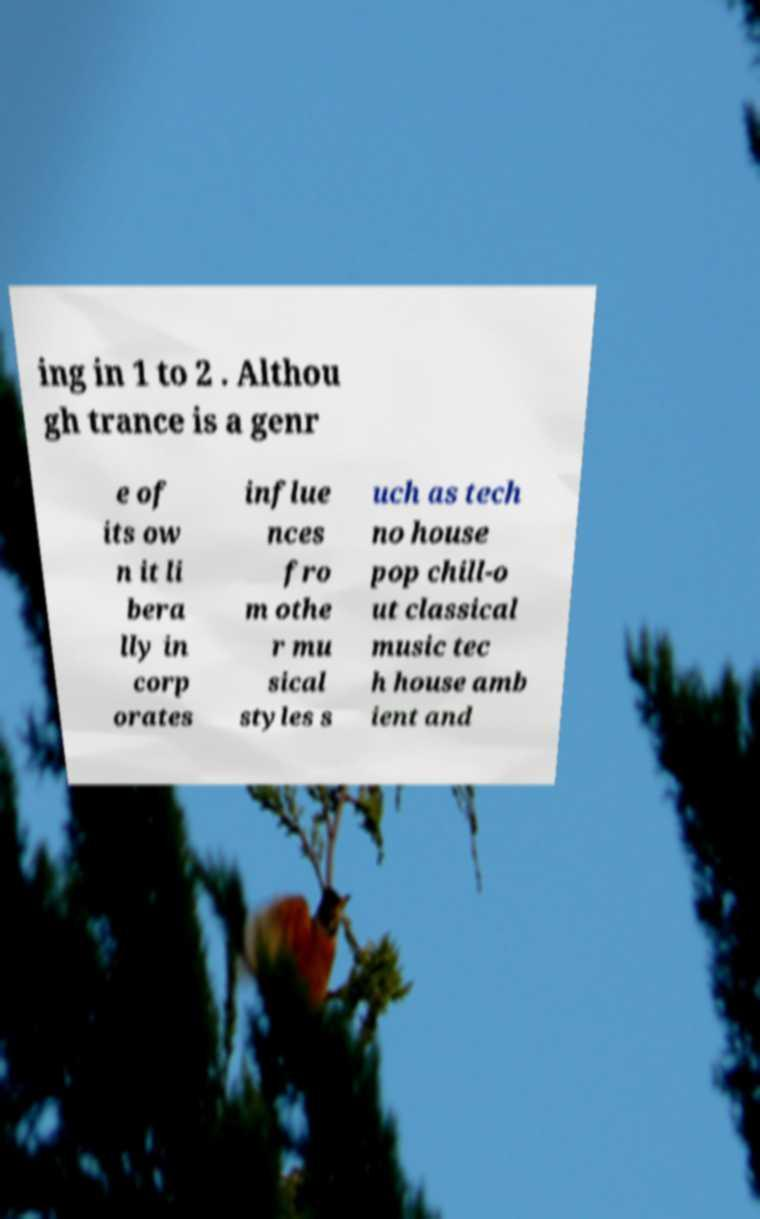There's text embedded in this image that I need extracted. Can you transcribe it verbatim? ing in 1 to 2 . Althou gh trance is a genr e of its ow n it li bera lly in corp orates influe nces fro m othe r mu sical styles s uch as tech no house pop chill-o ut classical music tec h house amb ient and 